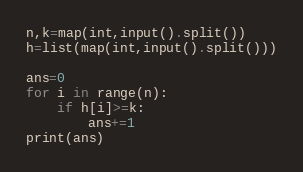<code> <loc_0><loc_0><loc_500><loc_500><_Python_>n,k=map(int,input().split())
h=list(map(int,input().split()))

ans=0
for i in range(n):
    if h[i]>=k:
        ans+=1
print(ans)
</code> 